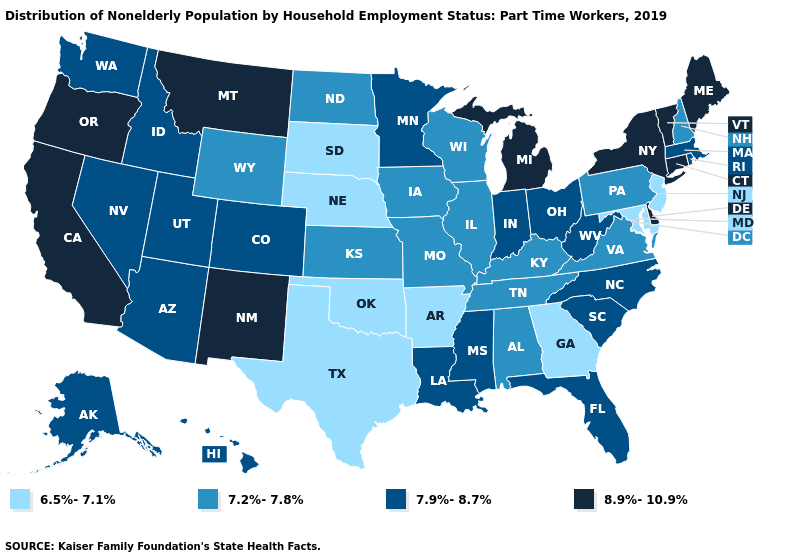Among the states that border Washington , which have the highest value?
Write a very short answer. Oregon. What is the lowest value in the USA?
Keep it brief. 6.5%-7.1%. Name the states that have a value in the range 6.5%-7.1%?
Short answer required. Arkansas, Georgia, Maryland, Nebraska, New Jersey, Oklahoma, South Dakota, Texas. What is the value of Washington?
Give a very brief answer. 7.9%-8.7%. Name the states that have a value in the range 6.5%-7.1%?
Answer briefly. Arkansas, Georgia, Maryland, Nebraska, New Jersey, Oklahoma, South Dakota, Texas. Name the states that have a value in the range 7.9%-8.7%?
Answer briefly. Alaska, Arizona, Colorado, Florida, Hawaii, Idaho, Indiana, Louisiana, Massachusetts, Minnesota, Mississippi, Nevada, North Carolina, Ohio, Rhode Island, South Carolina, Utah, Washington, West Virginia. What is the value of California?
Write a very short answer. 8.9%-10.9%. Name the states that have a value in the range 8.9%-10.9%?
Short answer required. California, Connecticut, Delaware, Maine, Michigan, Montana, New Mexico, New York, Oregon, Vermont. Name the states that have a value in the range 7.9%-8.7%?
Write a very short answer. Alaska, Arizona, Colorado, Florida, Hawaii, Idaho, Indiana, Louisiana, Massachusetts, Minnesota, Mississippi, Nevada, North Carolina, Ohio, Rhode Island, South Carolina, Utah, Washington, West Virginia. Does West Virginia have a lower value than New York?
Give a very brief answer. Yes. How many symbols are there in the legend?
Be succinct. 4. Name the states that have a value in the range 7.9%-8.7%?
Be succinct. Alaska, Arizona, Colorado, Florida, Hawaii, Idaho, Indiana, Louisiana, Massachusetts, Minnesota, Mississippi, Nevada, North Carolina, Ohio, Rhode Island, South Carolina, Utah, Washington, West Virginia. Name the states that have a value in the range 7.9%-8.7%?
Quick response, please. Alaska, Arizona, Colorado, Florida, Hawaii, Idaho, Indiana, Louisiana, Massachusetts, Minnesota, Mississippi, Nevada, North Carolina, Ohio, Rhode Island, South Carolina, Utah, Washington, West Virginia. Which states hav the highest value in the South?
Quick response, please. Delaware. 